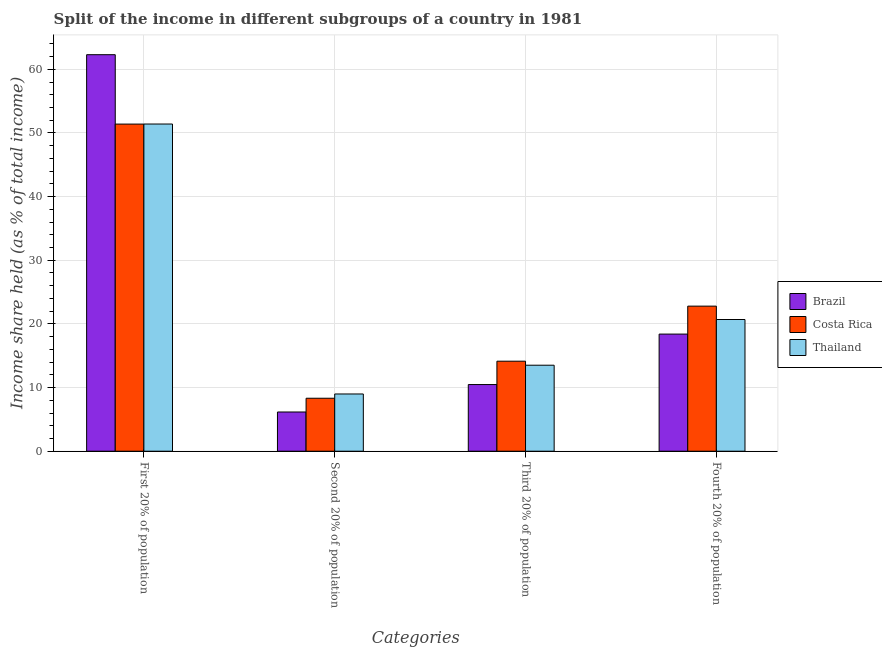Are the number of bars on each tick of the X-axis equal?
Make the answer very short. Yes. How many bars are there on the 1st tick from the right?
Ensure brevity in your answer.  3. What is the label of the 3rd group of bars from the left?
Provide a succinct answer. Third 20% of population. What is the share of the income held by third 20% of the population in Costa Rica?
Offer a terse response. 14.14. Across all countries, what is the maximum share of the income held by second 20% of the population?
Keep it short and to the point. 8.99. Across all countries, what is the minimum share of the income held by first 20% of the population?
Offer a terse response. 51.39. In which country was the share of the income held by second 20% of the population maximum?
Provide a succinct answer. Thailand. What is the total share of the income held by fourth 20% of the population in the graph?
Your response must be concise. 61.88. What is the difference between the share of the income held by second 20% of the population in Costa Rica and that in Thailand?
Give a very brief answer. -0.67. What is the difference between the share of the income held by second 20% of the population in Brazil and the share of the income held by first 20% of the population in Thailand?
Your answer should be very brief. -45.24. What is the average share of the income held by third 20% of the population per country?
Your answer should be very brief. 12.71. What is the difference between the share of the income held by second 20% of the population and share of the income held by third 20% of the population in Thailand?
Offer a terse response. -4.52. What is the ratio of the share of the income held by third 20% of the population in Thailand to that in Brazil?
Your response must be concise. 1.29. Is the share of the income held by fourth 20% of the population in Costa Rica less than that in Brazil?
Your answer should be compact. No. Is the difference between the share of the income held by third 20% of the population in Brazil and Thailand greater than the difference between the share of the income held by first 20% of the population in Brazil and Thailand?
Offer a very short reply. No. What is the difference between the highest and the second highest share of the income held by third 20% of the population?
Give a very brief answer. 0.63. What is the difference between the highest and the lowest share of the income held by second 20% of the population?
Offer a terse response. 2.83. In how many countries, is the share of the income held by fourth 20% of the population greater than the average share of the income held by fourth 20% of the population taken over all countries?
Keep it short and to the point. 2. What does the 3rd bar from the left in Third 20% of population represents?
Your response must be concise. Thailand. What does the 1st bar from the right in Fourth 20% of population represents?
Provide a succinct answer. Thailand. Are the values on the major ticks of Y-axis written in scientific E-notation?
Make the answer very short. No. Does the graph contain any zero values?
Make the answer very short. No. Does the graph contain grids?
Offer a terse response. Yes. How many legend labels are there?
Offer a very short reply. 3. What is the title of the graph?
Provide a short and direct response. Split of the income in different subgroups of a country in 1981. Does "Sao Tome and Principe" appear as one of the legend labels in the graph?
Make the answer very short. No. What is the label or title of the X-axis?
Give a very brief answer. Categories. What is the label or title of the Y-axis?
Your response must be concise. Income share held (as % of total income). What is the Income share held (as % of total income) of Brazil in First 20% of population?
Make the answer very short. 62.29. What is the Income share held (as % of total income) in Costa Rica in First 20% of population?
Give a very brief answer. 51.39. What is the Income share held (as % of total income) in Thailand in First 20% of population?
Provide a short and direct response. 51.4. What is the Income share held (as % of total income) in Brazil in Second 20% of population?
Give a very brief answer. 6.16. What is the Income share held (as % of total income) in Costa Rica in Second 20% of population?
Ensure brevity in your answer.  8.32. What is the Income share held (as % of total income) of Thailand in Second 20% of population?
Provide a succinct answer. 8.99. What is the Income share held (as % of total income) in Brazil in Third 20% of population?
Give a very brief answer. 10.47. What is the Income share held (as % of total income) in Costa Rica in Third 20% of population?
Give a very brief answer. 14.14. What is the Income share held (as % of total income) of Thailand in Third 20% of population?
Provide a succinct answer. 13.51. What is the Income share held (as % of total income) in Brazil in Fourth 20% of population?
Offer a terse response. 18.4. What is the Income share held (as % of total income) of Costa Rica in Fourth 20% of population?
Offer a terse response. 22.79. What is the Income share held (as % of total income) in Thailand in Fourth 20% of population?
Provide a succinct answer. 20.69. Across all Categories, what is the maximum Income share held (as % of total income) in Brazil?
Keep it short and to the point. 62.29. Across all Categories, what is the maximum Income share held (as % of total income) of Costa Rica?
Give a very brief answer. 51.39. Across all Categories, what is the maximum Income share held (as % of total income) in Thailand?
Give a very brief answer. 51.4. Across all Categories, what is the minimum Income share held (as % of total income) of Brazil?
Give a very brief answer. 6.16. Across all Categories, what is the minimum Income share held (as % of total income) in Costa Rica?
Offer a very short reply. 8.32. Across all Categories, what is the minimum Income share held (as % of total income) in Thailand?
Keep it short and to the point. 8.99. What is the total Income share held (as % of total income) in Brazil in the graph?
Keep it short and to the point. 97.32. What is the total Income share held (as % of total income) of Costa Rica in the graph?
Your response must be concise. 96.64. What is the total Income share held (as % of total income) of Thailand in the graph?
Ensure brevity in your answer.  94.59. What is the difference between the Income share held (as % of total income) in Brazil in First 20% of population and that in Second 20% of population?
Offer a very short reply. 56.13. What is the difference between the Income share held (as % of total income) of Costa Rica in First 20% of population and that in Second 20% of population?
Keep it short and to the point. 43.07. What is the difference between the Income share held (as % of total income) in Thailand in First 20% of population and that in Second 20% of population?
Keep it short and to the point. 42.41. What is the difference between the Income share held (as % of total income) in Brazil in First 20% of population and that in Third 20% of population?
Keep it short and to the point. 51.82. What is the difference between the Income share held (as % of total income) of Costa Rica in First 20% of population and that in Third 20% of population?
Provide a succinct answer. 37.25. What is the difference between the Income share held (as % of total income) of Thailand in First 20% of population and that in Third 20% of population?
Your answer should be compact. 37.89. What is the difference between the Income share held (as % of total income) of Brazil in First 20% of population and that in Fourth 20% of population?
Keep it short and to the point. 43.89. What is the difference between the Income share held (as % of total income) in Costa Rica in First 20% of population and that in Fourth 20% of population?
Your answer should be very brief. 28.6. What is the difference between the Income share held (as % of total income) of Thailand in First 20% of population and that in Fourth 20% of population?
Ensure brevity in your answer.  30.71. What is the difference between the Income share held (as % of total income) in Brazil in Second 20% of population and that in Third 20% of population?
Offer a very short reply. -4.31. What is the difference between the Income share held (as % of total income) of Costa Rica in Second 20% of population and that in Third 20% of population?
Your answer should be compact. -5.82. What is the difference between the Income share held (as % of total income) in Thailand in Second 20% of population and that in Third 20% of population?
Your answer should be compact. -4.52. What is the difference between the Income share held (as % of total income) in Brazil in Second 20% of population and that in Fourth 20% of population?
Ensure brevity in your answer.  -12.24. What is the difference between the Income share held (as % of total income) in Costa Rica in Second 20% of population and that in Fourth 20% of population?
Provide a succinct answer. -14.47. What is the difference between the Income share held (as % of total income) of Brazil in Third 20% of population and that in Fourth 20% of population?
Keep it short and to the point. -7.93. What is the difference between the Income share held (as % of total income) of Costa Rica in Third 20% of population and that in Fourth 20% of population?
Provide a succinct answer. -8.65. What is the difference between the Income share held (as % of total income) in Thailand in Third 20% of population and that in Fourth 20% of population?
Your response must be concise. -7.18. What is the difference between the Income share held (as % of total income) in Brazil in First 20% of population and the Income share held (as % of total income) in Costa Rica in Second 20% of population?
Give a very brief answer. 53.97. What is the difference between the Income share held (as % of total income) in Brazil in First 20% of population and the Income share held (as % of total income) in Thailand in Second 20% of population?
Offer a terse response. 53.3. What is the difference between the Income share held (as % of total income) of Costa Rica in First 20% of population and the Income share held (as % of total income) of Thailand in Second 20% of population?
Keep it short and to the point. 42.4. What is the difference between the Income share held (as % of total income) of Brazil in First 20% of population and the Income share held (as % of total income) of Costa Rica in Third 20% of population?
Give a very brief answer. 48.15. What is the difference between the Income share held (as % of total income) in Brazil in First 20% of population and the Income share held (as % of total income) in Thailand in Third 20% of population?
Provide a short and direct response. 48.78. What is the difference between the Income share held (as % of total income) of Costa Rica in First 20% of population and the Income share held (as % of total income) of Thailand in Third 20% of population?
Your response must be concise. 37.88. What is the difference between the Income share held (as % of total income) in Brazil in First 20% of population and the Income share held (as % of total income) in Costa Rica in Fourth 20% of population?
Your response must be concise. 39.5. What is the difference between the Income share held (as % of total income) in Brazil in First 20% of population and the Income share held (as % of total income) in Thailand in Fourth 20% of population?
Give a very brief answer. 41.6. What is the difference between the Income share held (as % of total income) in Costa Rica in First 20% of population and the Income share held (as % of total income) in Thailand in Fourth 20% of population?
Keep it short and to the point. 30.7. What is the difference between the Income share held (as % of total income) of Brazil in Second 20% of population and the Income share held (as % of total income) of Costa Rica in Third 20% of population?
Your answer should be compact. -7.98. What is the difference between the Income share held (as % of total income) of Brazil in Second 20% of population and the Income share held (as % of total income) of Thailand in Third 20% of population?
Keep it short and to the point. -7.35. What is the difference between the Income share held (as % of total income) of Costa Rica in Second 20% of population and the Income share held (as % of total income) of Thailand in Third 20% of population?
Offer a terse response. -5.19. What is the difference between the Income share held (as % of total income) of Brazil in Second 20% of population and the Income share held (as % of total income) of Costa Rica in Fourth 20% of population?
Ensure brevity in your answer.  -16.63. What is the difference between the Income share held (as % of total income) of Brazil in Second 20% of population and the Income share held (as % of total income) of Thailand in Fourth 20% of population?
Provide a succinct answer. -14.53. What is the difference between the Income share held (as % of total income) in Costa Rica in Second 20% of population and the Income share held (as % of total income) in Thailand in Fourth 20% of population?
Keep it short and to the point. -12.37. What is the difference between the Income share held (as % of total income) in Brazil in Third 20% of population and the Income share held (as % of total income) in Costa Rica in Fourth 20% of population?
Your response must be concise. -12.32. What is the difference between the Income share held (as % of total income) of Brazil in Third 20% of population and the Income share held (as % of total income) of Thailand in Fourth 20% of population?
Your answer should be very brief. -10.22. What is the difference between the Income share held (as % of total income) of Costa Rica in Third 20% of population and the Income share held (as % of total income) of Thailand in Fourth 20% of population?
Ensure brevity in your answer.  -6.55. What is the average Income share held (as % of total income) in Brazil per Categories?
Give a very brief answer. 24.33. What is the average Income share held (as % of total income) of Costa Rica per Categories?
Keep it short and to the point. 24.16. What is the average Income share held (as % of total income) of Thailand per Categories?
Your answer should be compact. 23.65. What is the difference between the Income share held (as % of total income) in Brazil and Income share held (as % of total income) in Thailand in First 20% of population?
Provide a succinct answer. 10.89. What is the difference between the Income share held (as % of total income) in Costa Rica and Income share held (as % of total income) in Thailand in First 20% of population?
Ensure brevity in your answer.  -0.01. What is the difference between the Income share held (as % of total income) of Brazil and Income share held (as % of total income) of Costa Rica in Second 20% of population?
Keep it short and to the point. -2.16. What is the difference between the Income share held (as % of total income) in Brazil and Income share held (as % of total income) in Thailand in Second 20% of population?
Offer a very short reply. -2.83. What is the difference between the Income share held (as % of total income) of Costa Rica and Income share held (as % of total income) of Thailand in Second 20% of population?
Your answer should be very brief. -0.67. What is the difference between the Income share held (as % of total income) in Brazil and Income share held (as % of total income) in Costa Rica in Third 20% of population?
Your answer should be very brief. -3.67. What is the difference between the Income share held (as % of total income) in Brazil and Income share held (as % of total income) in Thailand in Third 20% of population?
Keep it short and to the point. -3.04. What is the difference between the Income share held (as % of total income) of Costa Rica and Income share held (as % of total income) of Thailand in Third 20% of population?
Offer a very short reply. 0.63. What is the difference between the Income share held (as % of total income) in Brazil and Income share held (as % of total income) in Costa Rica in Fourth 20% of population?
Make the answer very short. -4.39. What is the difference between the Income share held (as % of total income) in Brazil and Income share held (as % of total income) in Thailand in Fourth 20% of population?
Your response must be concise. -2.29. What is the difference between the Income share held (as % of total income) of Costa Rica and Income share held (as % of total income) of Thailand in Fourth 20% of population?
Offer a terse response. 2.1. What is the ratio of the Income share held (as % of total income) in Brazil in First 20% of population to that in Second 20% of population?
Ensure brevity in your answer.  10.11. What is the ratio of the Income share held (as % of total income) of Costa Rica in First 20% of population to that in Second 20% of population?
Your answer should be compact. 6.18. What is the ratio of the Income share held (as % of total income) in Thailand in First 20% of population to that in Second 20% of population?
Your answer should be compact. 5.72. What is the ratio of the Income share held (as % of total income) of Brazil in First 20% of population to that in Third 20% of population?
Provide a short and direct response. 5.95. What is the ratio of the Income share held (as % of total income) in Costa Rica in First 20% of population to that in Third 20% of population?
Give a very brief answer. 3.63. What is the ratio of the Income share held (as % of total income) in Thailand in First 20% of population to that in Third 20% of population?
Offer a very short reply. 3.8. What is the ratio of the Income share held (as % of total income) of Brazil in First 20% of population to that in Fourth 20% of population?
Offer a very short reply. 3.39. What is the ratio of the Income share held (as % of total income) of Costa Rica in First 20% of population to that in Fourth 20% of population?
Give a very brief answer. 2.25. What is the ratio of the Income share held (as % of total income) in Thailand in First 20% of population to that in Fourth 20% of population?
Offer a terse response. 2.48. What is the ratio of the Income share held (as % of total income) in Brazil in Second 20% of population to that in Third 20% of population?
Offer a terse response. 0.59. What is the ratio of the Income share held (as % of total income) of Costa Rica in Second 20% of population to that in Third 20% of population?
Provide a short and direct response. 0.59. What is the ratio of the Income share held (as % of total income) in Thailand in Second 20% of population to that in Third 20% of population?
Ensure brevity in your answer.  0.67. What is the ratio of the Income share held (as % of total income) in Brazil in Second 20% of population to that in Fourth 20% of population?
Your answer should be compact. 0.33. What is the ratio of the Income share held (as % of total income) of Costa Rica in Second 20% of population to that in Fourth 20% of population?
Ensure brevity in your answer.  0.37. What is the ratio of the Income share held (as % of total income) of Thailand in Second 20% of population to that in Fourth 20% of population?
Your answer should be very brief. 0.43. What is the ratio of the Income share held (as % of total income) of Brazil in Third 20% of population to that in Fourth 20% of population?
Your answer should be compact. 0.57. What is the ratio of the Income share held (as % of total income) of Costa Rica in Third 20% of population to that in Fourth 20% of population?
Your answer should be compact. 0.62. What is the ratio of the Income share held (as % of total income) in Thailand in Third 20% of population to that in Fourth 20% of population?
Ensure brevity in your answer.  0.65. What is the difference between the highest and the second highest Income share held (as % of total income) of Brazil?
Give a very brief answer. 43.89. What is the difference between the highest and the second highest Income share held (as % of total income) in Costa Rica?
Ensure brevity in your answer.  28.6. What is the difference between the highest and the second highest Income share held (as % of total income) in Thailand?
Offer a terse response. 30.71. What is the difference between the highest and the lowest Income share held (as % of total income) of Brazil?
Give a very brief answer. 56.13. What is the difference between the highest and the lowest Income share held (as % of total income) in Costa Rica?
Make the answer very short. 43.07. What is the difference between the highest and the lowest Income share held (as % of total income) of Thailand?
Your answer should be compact. 42.41. 